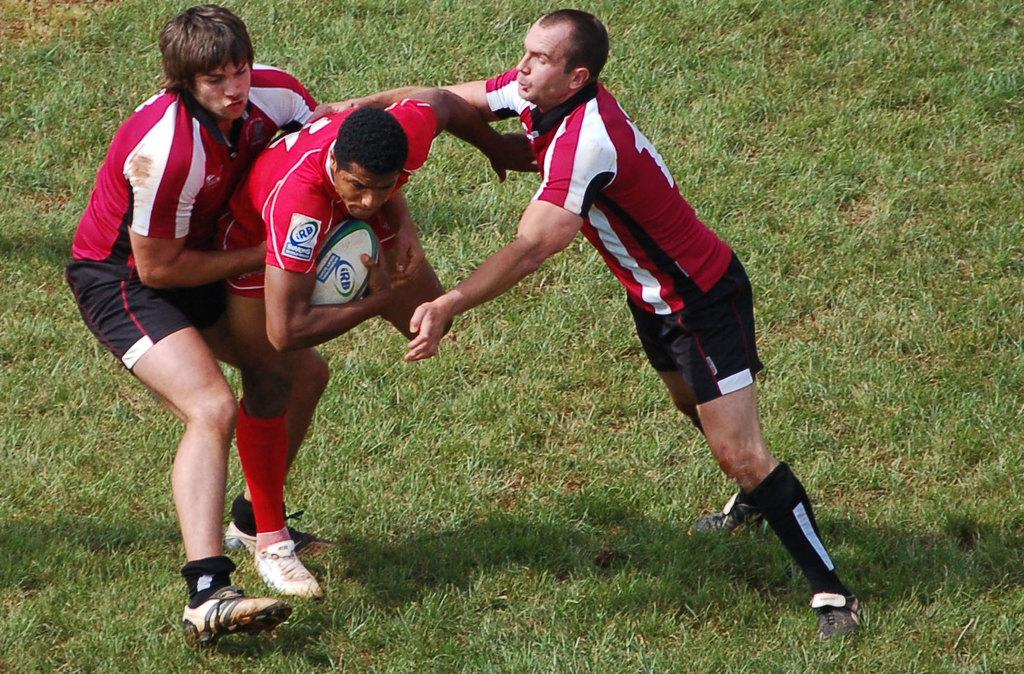How many people are in the image? There are three people in the image. What colors are the dresses worn by the people? One person is wearing a red dress, one person is wearing a white dress, and one person is wearing a black dress. What is one person holding in the image? One person is holding a ball. What type of surface is visible in the image? There is green grass visible in the image. How many snails can be seen crawling on the red dress in the image? There are no snails visible in the image, as it features three people wearing different colored dresses and one person holding a ball on a grassy surface. 